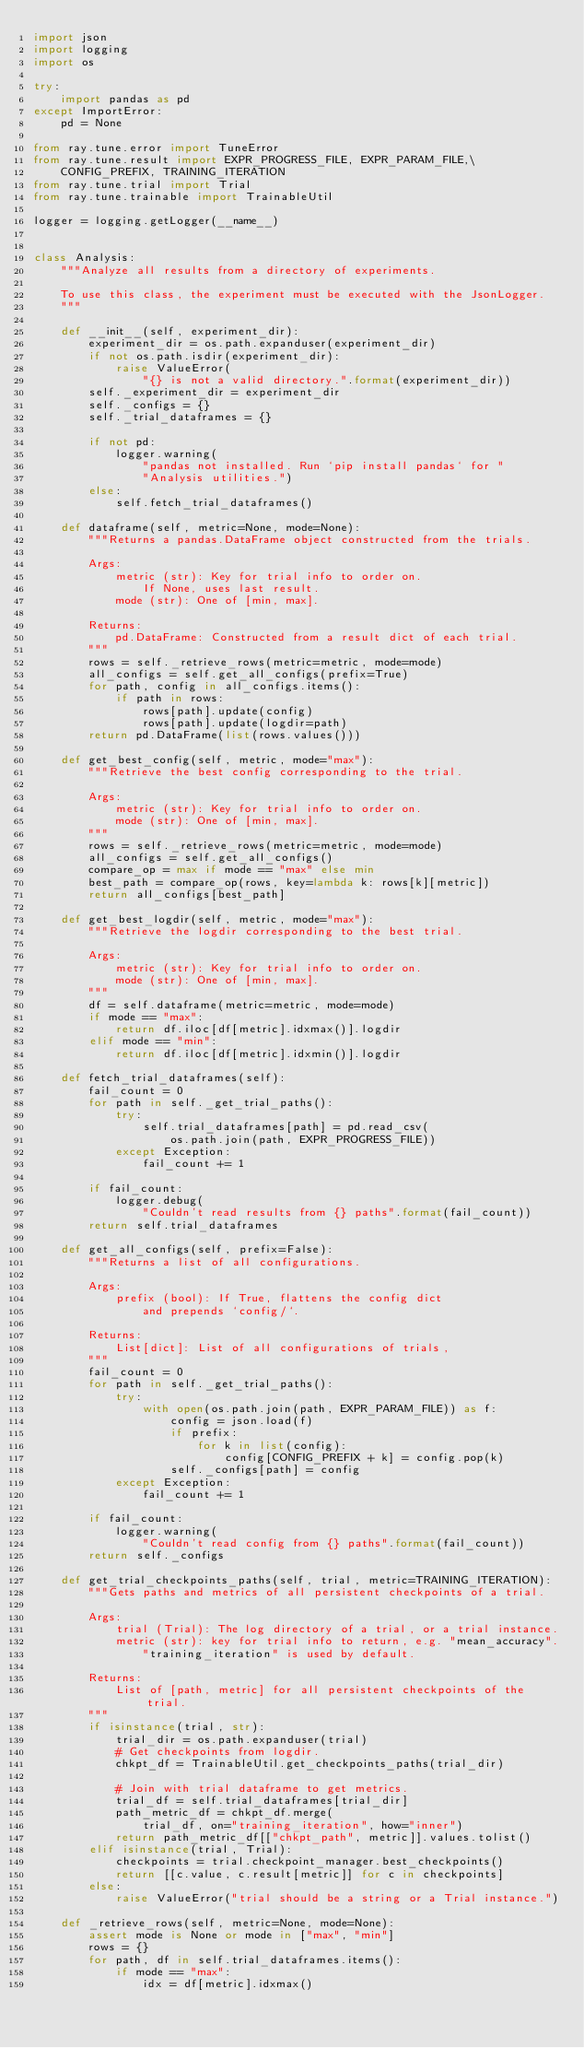<code> <loc_0><loc_0><loc_500><loc_500><_Python_>import json
import logging
import os

try:
    import pandas as pd
except ImportError:
    pd = None

from ray.tune.error import TuneError
from ray.tune.result import EXPR_PROGRESS_FILE, EXPR_PARAM_FILE,\
    CONFIG_PREFIX, TRAINING_ITERATION
from ray.tune.trial import Trial
from ray.tune.trainable import TrainableUtil

logger = logging.getLogger(__name__)


class Analysis:
    """Analyze all results from a directory of experiments.

    To use this class, the experiment must be executed with the JsonLogger.
    """

    def __init__(self, experiment_dir):
        experiment_dir = os.path.expanduser(experiment_dir)
        if not os.path.isdir(experiment_dir):
            raise ValueError(
                "{} is not a valid directory.".format(experiment_dir))
        self._experiment_dir = experiment_dir
        self._configs = {}
        self._trial_dataframes = {}

        if not pd:
            logger.warning(
                "pandas not installed. Run `pip install pandas` for "
                "Analysis utilities.")
        else:
            self.fetch_trial_dataframes()

    def dataframe(self, metric=None, mode=None):
        """Returns a pandas.DataFrame object constructed from the trials.

        Args:
            metric (str): Key for trial info to order on.
                If None, uses last result.
            mode (str): One of [min, max].

        Returns:
            pd.DataFrame: Constructed from a result dict of each trial.
        """
        rows = self._retrieve_rows(metric=metric, mode=mode)
        all_configs = self.get_all_configs(prefix=True)
        for path, config in all_configs.items():
            if path in rows:
                rows[path].update(config)
                rows[path].update(logdir=path)
        return pd.DataFrame(list(rows.values()))

    def get_best_config(self, metric, mode="max"):
        """Retrieve the best config corresponding to the trial.

        Args:
            metric (str): Key for trial info to order on.
            mode (str): One of [min, max].
        """
        rows = self._retrieve_rows(metric=metric, mode=mode)
        all_configs = self.get_all_configs()
        compare_op = max if mode == "max" else min
        best_path = compare_op(rows, key=lambda k: rows[k][metric])
        return all_configs[best_path]

    def get_best_logdir(self, metric, mode="max"):
        """Retrieve the logdir corresponding to the best trial.

        Args:
            metric (str): Key for trial info to order on.
            mode (str): One of [min, max].
        """
        df = self.dataframe(metric=metric, mode=mode)
        if mode == "max":
            return df.iloc[df[metric].idxmax()].logdir
        elif mode == "min":
            return df.iloc[df[metric].idxmin()].logdir

    def fetch_trial_dataframes(self):
        fail_count = 0
        for path in self._get_trial_paths():
            try:
                self.trial_dataframes[path] = pd.read_csv(
                    os.path.join(path, EXPR_PROGRESS_FILE))
            except Exception:
                fail_count += 1

        if fail_count:
            logger.debug(
                "Couldn't read results from {} paths".format(fail_count))
        return self.trial_dataframes

    def get_all_configs(self, prefix=False):
        """Returns a list of all configurations.

        Args:
            prefix (bool): If True, flattens the config dict
                and prepends `config/`.

        Returns:
            List[dict]: List of all configurations of trials,
        """
        fail_count = 0
        for path in self._get_trial_paths():
            try:
                with open(os.path.join(path, EXPR_PARAM_FILE)) as f:
                    config = json.load(f)
                    if prefix:
                        for k in list(config):
                            config[CONFIG_PREFIX + k] = config.pop(k)
                    self._configs[path] = config
            except Exception:
                fail_count += 1

        if fail_count:
            logger.warning(
                "Couldn't read config from {} paths".format(fail_count))
        return self._configs

    def get_trial_checkpoints_paths(self, trial, metric=TRAINING_ITERATION):
        """Gets paths and metrics of all persistent checkpoints of a trial.

        Args:
            trial (Trial): The log directory of a trial, or a trial instance.
            metric (str): key for trial info to return, e.g. "mean_accuracy".
                "training_iteration" is used by default.

        Returns:
            List of [path, metric] for all persistent checkpoints of the trial.
        """
        if isinstance(trial, str):
            trial_dir = os.path.expanduser(trial)
            # Get checkpoints from logdir.
            chkpt_df = TrainableUtil.get_checkpoints_paths(trial_dir)

            # Join with trial dataframe to get metrics.
            trial_df = self.trial_dataframes[trial_dir]
            path_metric_df = chkpt_df.merge(
                trial_df, on="training_iteration", how="inner")
            return path_metric_df[["chkpt_path", metric]].values.tolist()
        elif isinstance(trial, Trial):
            checkpoints = trial.checkpoint_manager.best_checkpoints()
            return [[c.value, c.result[metric]] for c in checkpoints]
        else:
            raise ValueError("trial should be a string or a Trial instance.")

    def _retrieve_rows(self, metric=None, mode=None):
        assert mode is None or mode in ["max", "min"]
        rows = {}
        for path, df in self.trial_dataframes.items():
            if mode == "max":
                idx = df[metric].idxmax()</code> 